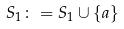Convert formula to latex. <formula><loc_0><loc_0><loc_500><loc_500>S _ { 1 } \colon = S _ { 1 } \cup \{ a \}</formula> 